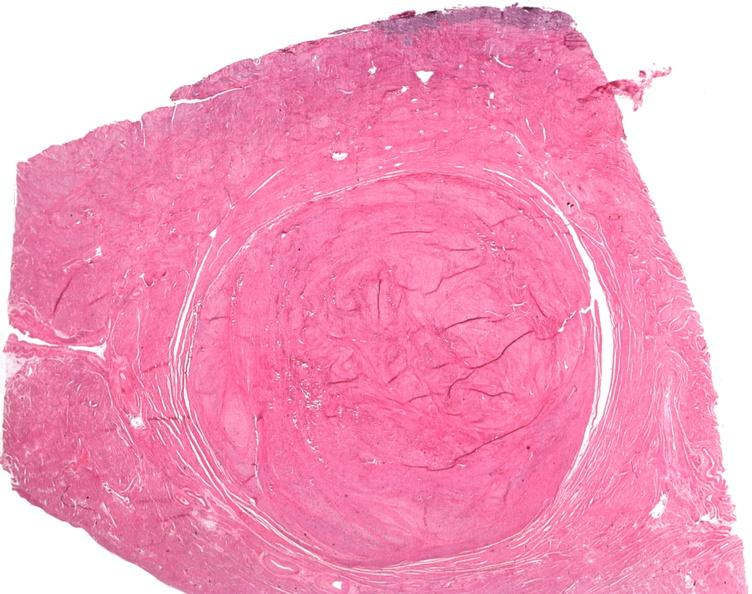where is this from?
Answer the question using a single word or phrase. Female reproductive system 